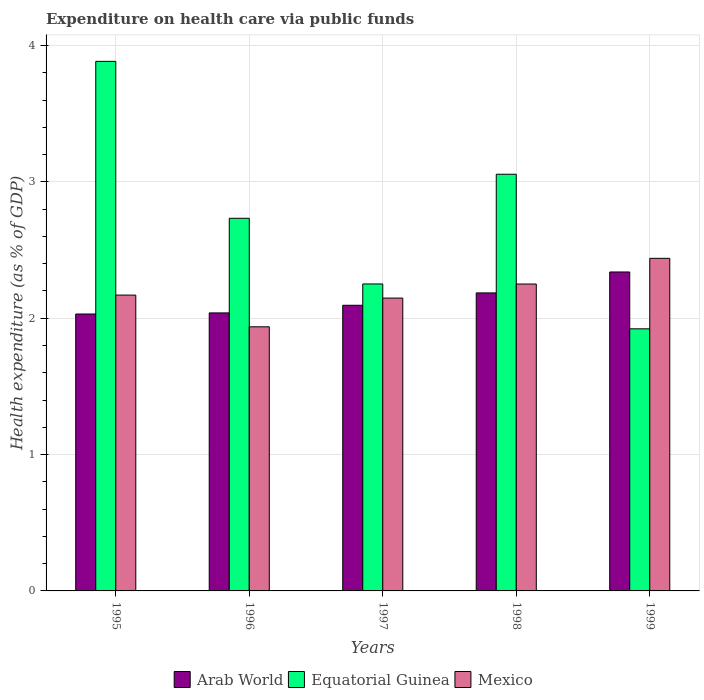How many groups of bars are there?
Provide a short and direct response. 5. What is the label of the 3rd group of bars from the left?
Give a very brief answer. 1997. In how many cases, is the number of bars for a given year not equal to the number of legend labels?
Keep it short and to the point. 0. What is the expenditure made on health care in Equatorial Guinea in 1997?
Keep it short and to the point. 2.25. Across all years, what is the maximum expenditure made on health care in Arab World?
Provide a succinct answer. 2.34. Across all years, what is the minimum expenditure made on health care in Mexico?
Give a very brief answer. 1.94. In which year was the expenditure made on health care in Mexico minimum?
Ensure brevity in your answer.  1996. What is the total expenditure made on health care in Mexico in the graph?
Provide a short and direct response. 10.94. What is the difference between the expenditure made on health care in Equatorial Guinea in 1996 and that in 1999?
Give a very brief answer. 0.81. What is the difference between the expenditure made on health care in Mexico in 1997 and the expenditure made on health care in Arab World in 1999?
Your answer should be very brief. -0.19. What is the average expenditure made on health care in Arab World per year?
Provide a short and direct response. 2.14. In the year 1998, what is the difference between the expenditure made on health care in Arab World and expenditure made on health care in Equatorial Guinea?
Your answer should be very brief. -0.87. What is the ratio of the expenditure made on health care in Equatorial Guinea in 1996 to that in 1999?
Provide a succinct answer. 1.42. Is the expenditure made on health care in Arab World in 1997 less than that in 1999?
Your response must be concise. Yes. Is the difference between the expenditure made on health care in Arab World in 1996 and 1999 greater than the difference between the expenditure made on health care in Equatorial Guinea in 1996 and 1999?
Give a very brief answer. No. What is the difference between the highest and the second highest expenditure made on health care in Arab World?
Keep it short and to the point. 0.15. What is the difference between the highest and the lowest expenditure made on health care in Arab World?
Offer a very short reply. 0.31. What does the 3rd bar from the left in 1998 represents?
Your answer should be compact. Mexico. What does the 1st bar from the right in 1998 represents?
Your response must be concise. Mexico. Are all the bars in the graph horizontal?
Make the answer very short. No. How many years are there in the graph?
Provide a short and direct response. 5. Are the values on the major ticks of Y-axis written in scientific E-notation?
Your response must be concise. No. Does the graph contain grids?
Offer a very short reply. Yes. How are the legend labels stacked?
Your answer should be very brief. Horizontal. What is the title of the graph?
Provide a short and direct response. Expenditure on health care via public funds. Does "European Union" appear as one of the legend labels in the graph?
Provide a short and direct response. No. What is the label or title of the X-axis?
Give a very brief answer. Years. What is the label or title of the Y-axis?
Provide a succinct answer. Health expenditure (as % of GDP). What is the Health expenditure (as % of GDP) in Arab World in 1995?
Ensure brevity in your answer.  2.03. What is the Health expenditure (as % of GDP) of Equatorial Guinea in 1995?
Your response must be concise. 3.88. What is the Health expenditure (as % of GDP) of Mexico in 1995?
Your answer should be compact. 2.17. What is the Health expenditure (as % of GDP) in Arab World in 1996?
Make the answer very short. 2.04. What is the Health expenditure (as % of GDP) in Equatorial Guinea in 1996?
Provide a succinct answer. 2.73. What is the Health expenditure (as % of GDP) of Mexico in 1996?
Ensure brevity in your answer.  1.94. What is the Health expenditure (as % of GDP) of Arab World in 1997?
Ensure brevity in your answer.  2.09. What is the Health expenditure (as % of GDP) in Equatorial Guinea in 1997?
Keep it short and to the point. 2.25. What is the Health expenditure (as % of GDP) of Mexico in 1997?
Provide a succinct answer. 2.15. What is the Health expenditure (as % of GDP) in Arab World in 1998?
Your response must be concise. 2.19. What is the Health expenditure (as % of GDP) in Equatorial Guinea in 1998?
Keep it short and to the point. 3.06. What is the Health expenditure (as % of GDP) of Mexico in 1998?
Provide a short and direct response. 2.25. What is the Health expenditure (as % of GDP) of Arab World in 1999?
Make the answer very short. 2.34. What is the Health expenditure (as % of GDP) in Equatorial Guinea in 1999?
Offer a very short reply. 1.92. What is the Health expenditure (as % of GDP) of Mexico in 1999?
Give a very brief answer. 2.44. Across all years, what is the maximum Health expenditure (as % of GDP) of Arab World?
Offer a terse response. 2.34. Across all years, what is the maximum Health expenditure (as % of GDP) of Equatorial Guinea?
Give a very brief answer. 3.88. Across all years, what is the maximum Health expenditure (as % of GDP) in Mexico?
Give a very brief answer. 2.44. Across all years, what is the minimum Health expenditure (as % of GDP) in Arab World?
Give a very brief answer. 2.03. Across all years, what is the minimum Health expenditure (as % of GDP) in Equatorial Guinea?
Make the answer very short. 1.92. Across all years, what is the minimum Health expenditure (as % of GDP) of Mexico?
Offer a very short reply. 1.94. What is the total Health expenditure (as % of GDP) of Arab World in the graph?
Keep it short and to the point. 10.69. What is the total Health expenditure (as % of GDP) of Equatorial Guinea in the graph?
Ensure brevity in your answer.  13.85. What is the total Health expenditure (as % of GDP) of Mexico in the graph?
Your answer should be very brief. 10.94. What is the difference between the Health expenditure (as % of GDP) in Arab World in 1995 and that in 1996?
Your answer should be compact. -0.01. What is the difference between the Health expenditure (as % of GDP) of Equatorial Guinea in 1995 and that in 1996?
Your answer should be very brief. 1.15. What is the difference between the Health expenditure (as % of GDP) in Mexico in 1995 and that in 1996?
Give a very brief answer. 0.23. What is the difference between the Health expenditure (as % of GDP) of Arab World in 1995 and that in 1997?
Make the answer very short. -0.06. What is the difference between the Health expenditure (as % of GDP) of Equatorial Guinea in 1995 and that in 1997?
Ensure brevity in your answer.  1.63. What is the difference between the Health expenditure (as % of GDP) in Mexico in 1995 and that in 1997?
Your answer should be compact. 0.02. What is the difference between the Health expenditure (as % of GDP) of Arab World in 1995 and that in 1998?
Ensure brevity in your answer.  -0.15. What is the difference between the Health expenditure (as % of GDP) of Equatorial Guinea in 1995 and that in 1998?
Ensure brevity in your answer.  0.83. What is the difference between the Health expenditure (as % of GDP) of Mexico in 1995 and that in 1998?
Give a very brief answer. -0.08. What is the difference between the Health expenditure (as % of GDP) of Arab World in 1995 and that in 1999?
Your answer should be compact. -0.31. What is the difference between the Health expenditure (as % of GDP) of Equatorial Guinea in 1995 and that in 1999?
Provide a succinct answer. 1.96. What is the difference between the Health expenditure (as % of GDP) of Mexico in 1995 and that in 1999?
Offer a terse response. -0.27. What is the difference between the Health expenditure (as % of GDP) in Arab World in 1996 and that in 1997?
Offer a very short reply. -0.06. What is the difference between the Health expenditure (as % of GDP) of Equatorial Guinea in 1996 and that in 1997?
Offer a very short reply. 0.48. What is the difference between the Health expenditure (as % of GDP) in Mexico in 1996 and that in 1997?
Provide a short and direct response. -0.21. What is the difference between the Health expenditure (as % of GDP) of Arab World in 1996 and that in 1998?
Ensure brevity in your answer.  -0.15. What is the difference between the Health expenditure (as % of GDP) in Equatorial Guinea in 1996 and that in 1998?
Provide a short and direct response. -0.32. What is the difference between the Health expenditure (as % of GDP) in Mexico in 1996 and that in 1998?
Give a very brief answer. -0.31. What is the difference between the Health expenditure (as % of GDP) in Arab World in 1996 and that in 1999?
Your answer should be very brief. -0.3. What is the difference between the Health expenditure (as % of GDP) of Equatorial Guinea in 1996 and that in 1999?
Keep it short and to the point. 0.81. What is the difference between the Health expenditure (as % of GDP) in Mexico in 1996 and that in 1999?
Your answer should be compact. -0.5. What is the difference between the Health expenditure (as % of GDP) of Arab World in 1997 and that in 1998?
Offer a very short reply. -0.09. What is the difference between the Health expenditure (as % of GDP) in Equatorial Guinea in 1997 and that in 1998?
Keep it short and to the point. -0.8. What is the difference between the Health expenditure (as % of GDP) in Mexico in 1997 and that in 1998?
Your answer should be compact. -0.1. What is the difference between the Health expenditure (as % of GDP) in Arab World in 1997 and that in 1999?
Make the answer very short. -0.24. What is the difference between the Health expenditure (as % of GDP) of Equatorial Guinea in 1997 and that in 1999?
Provide a short and direct response. 0.33. What is the difference between the Health expenditure (as % of GDP) in Mexico in 1997 and that in 1999?
Your answer should be very brief. -0.29. What is the difference between the Health expenditure (as % of GDP) in Arab World in 1998 and that in 1999?
Give a very brief answer. -0.15. What is the difference between the Health expenditure (as % of GDP) of Equatorial Guinea in 1998 and that in 1999?
Offer a terse response. 1.13. What is the difference between the Health expenditure (as % of GDP) of Mexico in 1998 and that in 1999?
Make the answer very short. -0.19. What is the difference between the Health expenditure (as % of GDP) in Arab World in 1995 and the Health expenditure (as % of GDP) in Equatorial Guinea in 1996?
Provide a short and direct response. -0.7. What is the difference between the Health expenditure (as % of GDP) in Arab World in 1995 and the Health expenditure (as % of GDP) in Mexico in 1996?
Your response must be concise. 0.09. What is the difference between the Health expenditure (as % of GDP) in Equatorial Guinea in 1995 and the Health expenditure (as % of GDP) in Mexico in 1996?
Provide a succinct answer. 1.95. What is the difference between the Health expenditure (as % of GDP) in Arab World in 1995 and the Health expenditure (as % of GDP) in Equatorial Guinea in 1997?
Offer a very short reply. -0.22. What is the difference between the Health expenditure (as % of GDP) of Arab World in 1995 and the Health expenditure (as % of GDP) of Mexico in 1997?
Provide a succinct answer. -0.12. What is the difference between the Health expenditure (as % of GDP) of Equatorial Guinea in 1995 and the Health expenditure (as % of GDP) of Mexico in 1997?
Give a very brief answer. 1.74. What is the difference between the Health expenditure (as % of GDP) of Arab World in 1995 and the Health expenditure (as % of GDP) of Equatorial Guinea in 1998?
Provide a short and direct response. -1.02. What is the difference between the Health expenditure (as % of GDP) of Arab World in 1995 and the Health expenditure (as % of GDP) of Mexico in 1998?
Your answer should be very brief. -0.22. What is the difference between the Health expenditure (as % of GDP) of Equatorial Guinea in 1995 and the Health expenditure (as % of GDP) of Mexico in 1998?
Provide a short and direct response. 1.63. What is the difference between the Health expenditure (as % of GDP) in Arab World in 1995 and the Health expenditure (as % of GDP) in Equatorial Guinea in 1999?
Keep it short and to the point. 0.11. What is the difference between the Health expenditure (as % of GDP) of Arab World in 1995 and the Health expenditure (as % of GDP) of Mexico in 1999?
Provide a succinct answer. -0.41. What is the difference between the Health expenditure (as % of GDP) in Equatorial Guinea in 1995 and the Health expenditure (as % of GDP) in Mexico in 1999?
Make the answer very short. 1.44. What is the difference between the Health expenditure (as % of GDP) of Arab World in 1996 and the Health expenditure (as % of GDP) of Equatorial Guinea in 1997?
Your answer should be compact. -0.21. What is the difference between the Health expenditure (as % of GDP) in Arab World in 1996 and the Health expenditure (as % of GDP) in Mexico in 1997?
Provide a short and direct response. -0.11. What is the difference between the Health expenditure (as % of GDP) of Equatorial Guinea in 1996 and the Health expenditure (as % of GDP) of Mexico in 1997?
Keep it short and to the point. 0.59. What is the difference between the Health expenditure (as % of GDP) of Arab World in 1996 and the Health expenditure (as % of GDP) of Equatorial Guinea in 1998?
Your answer should be compact. -1.02. What is the difference between the Health expenditure (as % of GDP) of Arab World in 1996 and the Health expenditure (as % of GDP) of Mexico in 1998?
Offer a very short reply. -0.21. What is the difference between the Health expenditure (as % of GDP) in Equatorial Guinea in 1996 and the Health expenditure (as % of GDP) in Mexico in 1998?
Keep it short and to the point. 0.48. What is the difference between the Health expenditure (as % of GDP) of Arab World in 1996 and the Health expenditure (as % of GDP) of Equatorial Guinea in 1999?
Give a very brief answer. 0.12. What is the difference between the Health expenditure (as % of GDP) in Arab World in 1996 and the Health expenditure (as % of GDP) in Mexico in 1999?
Your response must be concise. -0.4. What is the difference between the Health expenditure (as % of GDP) of Equatorial Guinea in 1996 and the Health expenditure (as % of GDP) of Mexico in 1999?
Give a very brief answer. 0.29. What is the difference between the Health expenditure (as % of GDP) of Arab World in 1997 and the Health expenditure (as % of GDP) of Equatorial Guinea in 1998?
Keep it short and to the point. -0.96. What is the difference between the Health expenditure (as % of GDP) of Arab World in 1997 and the Health expenditure (as % of GDP) of Mexico in 1998?
Ensure brevity in your answer.  -0.16. What is the difference between the Health expenditure (as % of GDP) in Arab World in 1997 and the Health expenditure (as % of GDP) in Equatorial Guinea in 1999?
Ensure brevity in your answer.  0.17. What is the difference between the Health expenditure (as % of GDP) of Arab World in 1997 and the Health expenditure (as % of GDP) of Mexico in 1999?
Ensure brevity in your answer.  -0.34. What is the difference between the Health expenditure (as % of GDP) in Equatorial Guinea in 1997 and the Health expenditure (as % of GDP) in Mexico in 1999?
Provide a short and direct response. -0.19. What is the difference between the Health expenditure (as % of GDP) in Arab World in 1998 and the Health expenditure (as % of GDP) in Equatorial Guinea in 1999?
Provide a succinct answer. 0.26. What is the difference between the Health expenditure (as % of GDP) of Arab World in 1998 and the Health expenditure (as % of GDP) of Mexico in 1999?
Your answer should be compact. -0.25. What is the difference between the Health expenditure (as % of GDP) in Equatorial Guinea in 1998 and the Health expenditure (as % of GDP) in Mexico in 1999?
Provide a succinct answer. 0.62. What is the average Health expenditure (as % of GDP) of Arab World per year?
Provide a succinct answer. 2.14. What is the average Health expenditure (as % of GDP) in Equatorial Guinea per year?
Your answer should be very brief. 2.77. What is the average Health expenditure (as % of GDP) of Mexico per year?
Your response must be concise. 2.19. In the year 1995, what is the difference between the Health expenditure (as % of GDP) in Arab World and Health expenditure (as % of GDP) in Equatorial Guinea?
Offer a terse response. -1.85. In the year 1995, what is the difference between the Health expenditure (as % of GDP) of Arab World and Health expenditure (as % of GDP) of Mexico?
Keep it short and to the point. -0.14. In the year 1995, what is the difference between the Health expenditure (as % of GDP) of Equatorial Guinea and Health expenditure (as % of GDP) of Mexico?
Provide a short and direct response. 1.71. In the year 1996, what is the difference between the Health expenditure (as % of GDP) of Arab World and Health expenditure (as % of GDP) of Equatorial Guinea?
Make the answer very short. -0.69. In the year 1996, what is the difference between the Health expenditure (as % of GDP) in Arab World and Health expenditure (as % of GDP) in Mexico?
Give a very brief answer. 0.1. In the year 1996, what is the difference between the Health expenditure (as % of GDP) of Equatorial Guinea and Health expenditure (as % of GDP) of Mexico?
Ensure brevity in your answer.  0.8. In the year 1997, what is the difference between the Health expenditure (as % of GDP) in Arab World and Health expenditure (as % of GDP) in Equatorial Guinea?
Your answer should be very brief. -0.16. In the year 1997, what is the difference between the Health expenditure (as % of GDP) of Arab World and Health expenditure (as % of GDP) of Mexico?
Provide a short and direct response. -0.05. In the year 1997, what is the difference between the Health expenditure (as % of GDP) in Equatorial Guinea and Health expenditure (as % of GDP) in Mexico?
Offer a terse response. 0.1. In the year 1998, what is the difference between the Health expenditure (as % of GDP) of Arab World and Health expenditure (as % of GDP) of Equatorial Guinea?
Your answer should be compact. -0.87. In the year 1998, what is the difference between the Health expenditure (as % of GDP) of Arab World and Health expenditure (as % of GDP) of Mexico?
Provide a short and direct response. -0.07. In the year 1998, what is the difference between the Health expenditure (as % of GDP) of Equatorial Guinea and Health expenditure (as % of GDP) of Mexico?
Make the answer very short. 0.81. In the year 1999, what is the difference between the Health expenditure (as % of GDP) in Arab World and Health expenditure (as % of GDP) in Equatorial Guinea?
Ensure brevity in your answer.  0.42. In the year 1999, what is the difference between the Health expenditure (as % of GDP) of Arab World and Health expenditure (as % of GDP) of Mexico?
Provide a succinct answer. -0.1. In the year 1999, what is the difference between the Health expenditure (as % of GDP) in Equatorial Guinea and Health expenditure (as % of GDP) in Mexico?
Give a very brief answer. -0.52. What is the ratio of the Health expenditure (as % of GDP) in Equatorial Guinea in 1995 to that in 1996?
Make the answer very short. 1.42. What is the ratio of the Health expenditure (as % of GDP) of Mexico in 1995 to that in 1996?
Your answer should be very brief. 1.12. What is the ratio of the Health expenditure (as % of GDP) in Arab World in 1995 to that in 1997?
Your response must be concise. 0.97. What is the ratio of the Health expenditure (as % of GDP) of Equatorial Guinea in 1995 to that in 1997?
Your answer should be compact. 1.73. What is the ratio of the Health expenditure (as % of GDP) in Mexico in 1995 to that in 1997?
Your response must be concise. 1.01. What is the ratio of the Health expenditure (as % of GDP) of Arab World in 1995 to that in 1998?
Your answer should be very brief. 0.93. What is the ratio of the Health expenditure (as % of GDP) of Equatorial Guinea in 1995 to that in 1998?
Provide a succinct answer. 1.27. What is the ratio of the Health expenditure (as % of GDP) in Arab World in 1995 to that in 1999?
Your response must be concise. 0.87. What is the ratio of the Health expenditure (as % of GDP) in Equatorial Guinea in 1995 to that in 1999?
Your answer should be very brief. 2.02. What is the ratio of the Health expenditure (as % of GDP) of Mexico in 1995 to that in 1999?
Give a very brief answer. 0.89. What is the ratio of the Health expenditure (as % of GDP) in Arab World in 1996 to that in 1997?
Your answer should be very brief. 0.97. What is the ratio of the Health expenditure (as % of GDP) in Equatorial Guinea in 1996 to that in 1997?
Keep it short and to the point. 1.21. What is the ratio of the Health expenditure (as % of GDP) of Mexico in 1996 to that in 1997?
Provide a short and direct response. 0.9. What is the ratio of the Health expenditure (as % of GDP) of Arab World in 1996 to that in 1998?
Give a very brief answer. 0.93. What is the ratio of the Health expenditure (as % of GDP) of Equatorial Guinea in 1996 to that in 1998?
Your answer should be very brief. 0.89. What is the ratio of the Health expenditure (as % of GDP) in Mexico in 1996 to that in 1998?
Your response must be concise. 0.86. What is the ratio of the Health expenditure (as % of GDP) of Arab World in 1996 to that in 1999?
Make the answer very short. 0.87. What is the ratio of the Health expenditure (as % of GDP) of Equatorial Guinea in 1996 to that in 1999?
Give a very brief answer. 1.42. What is the ratio of the Health expenditure (as % of GDP) in Mexico in 1996 to that in 1999?
Your answer should be compact. 0.79. What is the ratio of the Health expenditure (as % of GDP) of Arab World in 1997 to that in 1998?
Offer a terse response. 0.96. What is the ratio of the Health expenditure (as % of GDP) in Equatorial Guinea in 1997 to that in 1998?
Your response must be concise. 0.74. What is the ratio of the Health expenditure (as % of GDP) in Mexico in 1997 to that in 1998?
Provide a short and direct response. 0.95. What is the ratio of the Health expenditure (as % of GDP) in Arab World in 1997 to that in 1999?
Give a very brief answer. 0.9. What is the ratio of the Health expenditure (as % of GDP) of Equatorial Guinea in 1997 to that in 1999?
Offer a terse response. 1.17. What is the ratio of the Health expenditure (as % of GDP) of Mexico in 1997 to that in 1999?
Ensure brevity in your answer.  0.88. What is the ratio of the Health expenditure (as % of GDP) in Arab World in 1998 to that in 1999?
Keep it short and to the point. 0.93. What is the ratio of the Health expenditure (as % of GDP) of Equatorial Guinea in 1998 to that in 1999?
Offer a very short reply. 1.59. What is the ratio of the Health expenditure (as % of GDP) in Mexico in 1998 to that in 1999?
Provide a short and direct response. 0.92. What is the difference between the highest and the second highest Health expenditure (as % of GDP) of Arab World?
Offer a terse response. 0.15. What is the difference between the highest and the second highest Health expenditure (as % of GDP) in Equatorial Guinea?
Ensure brevity in your answer.  0.83. What is the difference between the highest and the second highest Health expenditure (as % of GDP) of Mexico?
Offer a very short reply. 0.19. What is the difference between the highest and the lowest Health expenditure (as % of GDP) of Arab World?
Make the answer very short. 0.31. What is the difference between the highest and the lowest Health expenditure (as % of GDP) of Equatorial Guinea?
Make the answer very short. 1.96. What is the difference between the highest and the lowest Health expenditure (as % of GDP) in Mexico?
Your answer should be very brief. 0.5. 